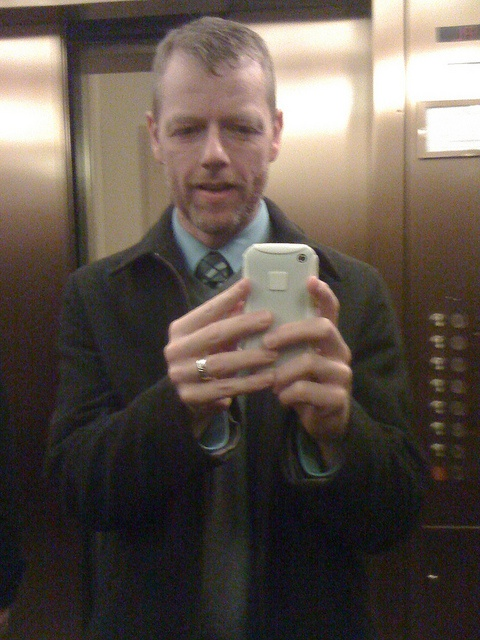Describe the objects in this image and their specific colors. I can see people in tan, black, gray, and darkgray tones, cell phone in tan, darkgray, gray, and ivory tones, and tie in tan, gray, black, and purple tones in this image. 